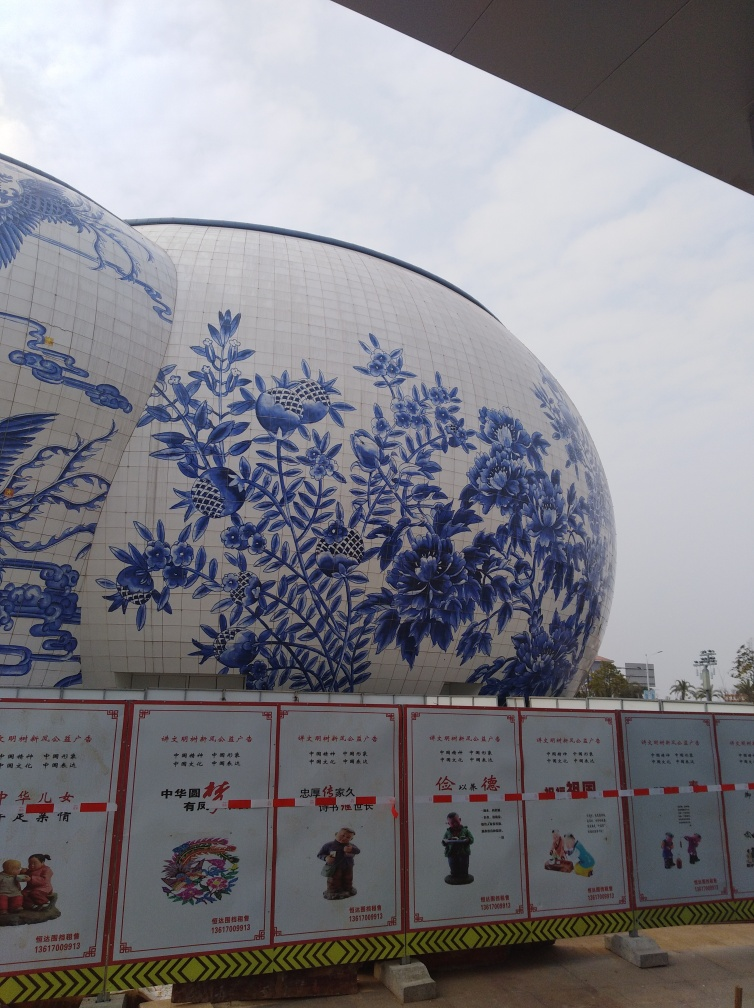Is there any noticeable distortion in the image? The image appears to be free from distortion, with clear lines and shapes. The striking blue-and-white spherical structure has a smooth and intact surface, featuring intricate patterns without any visible warping or pixelation. 